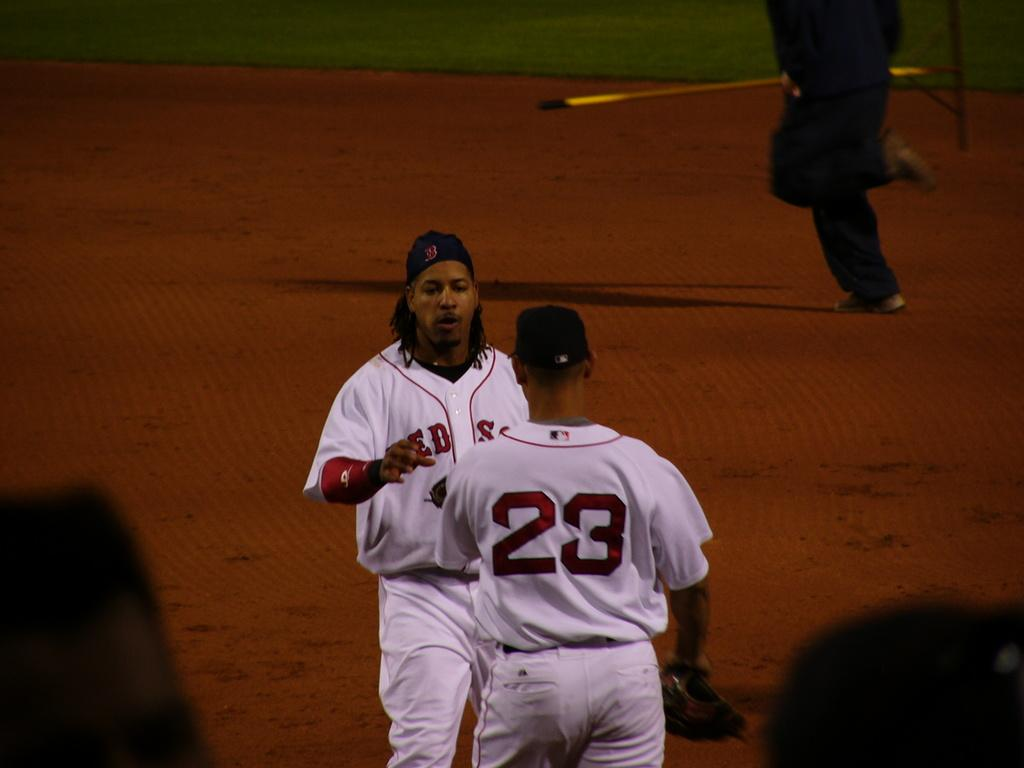<image>
Present a compact description of the photo's key features. A guy has a jersey on with the number 23 on the back. 